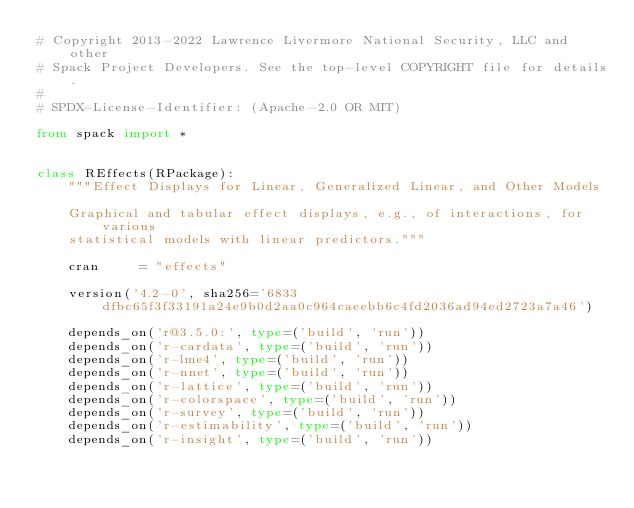Convert code to text. <code><loc_0><loc_0><loc_500><loc_500><_Python_># Copyright 2013-2022 Lawrence Livermore National Security, LLC and other
# Spack Project Developers. See the top-level COPYRIGHT file for details.
#
# SPDX-License-Identifier: (Apache-2.0 OR MIT)

from spack import *


class REffects(RPackage):
    """Effect Displays for Linear, Generalized Linear, and Other Models

    Graphical and tabular effect displays, e.g., of interactions, for various
    statistical models with linear predictors."""

    cran     = "effects"

    version('4.2-0', sha256='6833dfbc65f3f33191a24e9b0d2aa0c964caeebb6c4fd2036ad94ed2723a7a46')

    depends_on('r@3.5.0:', type=('build', 'run'))
    depends_on('r-cardata', type=('build', 'run'))
    depends_on('r-lme4', type=('build', 'run'))
    depends_on('r-nnet', type=('build', 'run'))
    depends_on('r-lattice', type=('build', 'run'))
    depends_on('r-colorspace', type=('build', 'run'))
    depends_on('r-survey', type=('build', 'run'))
    depends_on('r-estimability', type=('build', 'run'))
    depends_on('r-insight', type=('build', 'run'))
</code> 